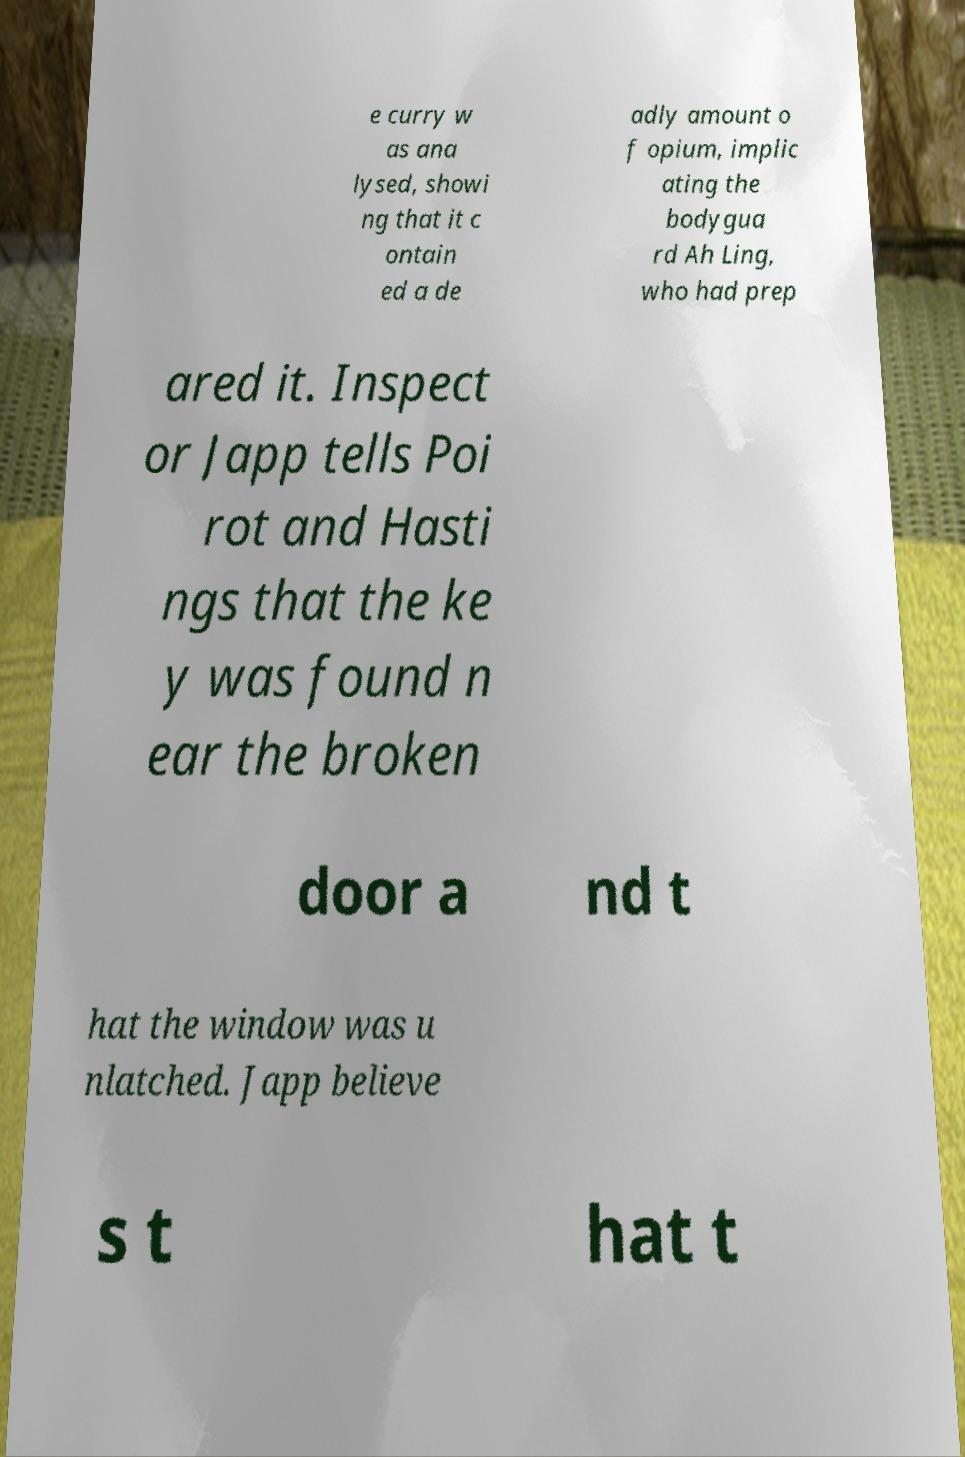Could you assist in decoding the text presented in this image and type it out clearly? e curry w as ana lysed, showi ng that it c ontain ed a de adly amount o f opium, implic ating the bodygua rd Ah Ling, who had prep ared it. Inspect or Japp tells Poi rot and Hasti ngs that the ke y was found n ear the broken door a nd t hat the window was u nlatched. Japp believe s t hat t 